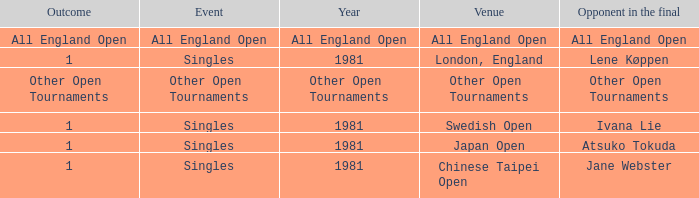Who was the Opponent in London, England with an Outcome of 1? Lene Køppen. 